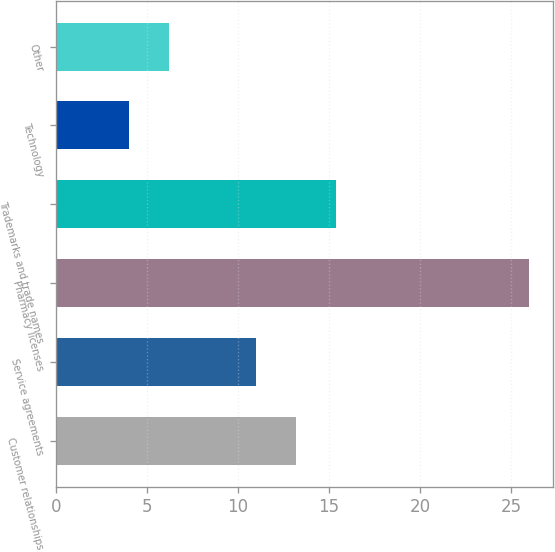<chart> <loc_0><loc_0><loc_500><loc_500><bar_chart><fcel>Customer relationships<fcel>Service agreements<fcel>Pharmacy licenses<fcel>Trademarks and trade names<fcel>Technology<fcel>Other<nl><fcel>13.2<fcel>11<fcel>26<fcel>15.4<fcel>4<fcel>6.2<nl></chart> 